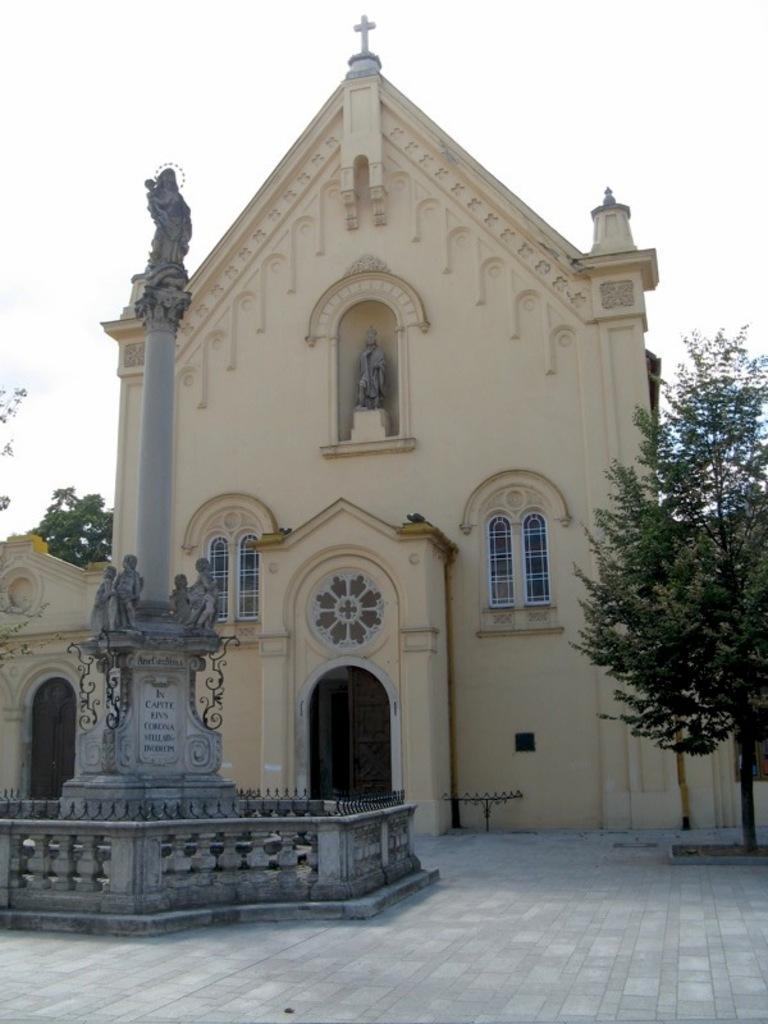Please provide a concise description of this image. In the middle of the picture, we see the stone carved statues and a pillar. Beside that, we see the railing. Behind that, we see a building and it might be the church. On the right side, we see a tree. In the background, we see the trees. At the top, we see the sky. 